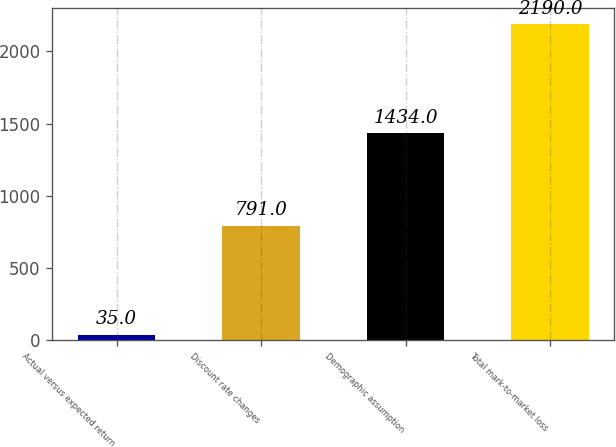<chart> <loc_0><loc_0><loc_500><loc_500><bar_chart><fcel>Actual versus expected return<fcel>Discount rate changes<fcel>Demographic assumption<fcel>Total mark-to-market loss<nl><fcel>35<fcel>791<fcel>1434<fcel>2190<nl></chart> 